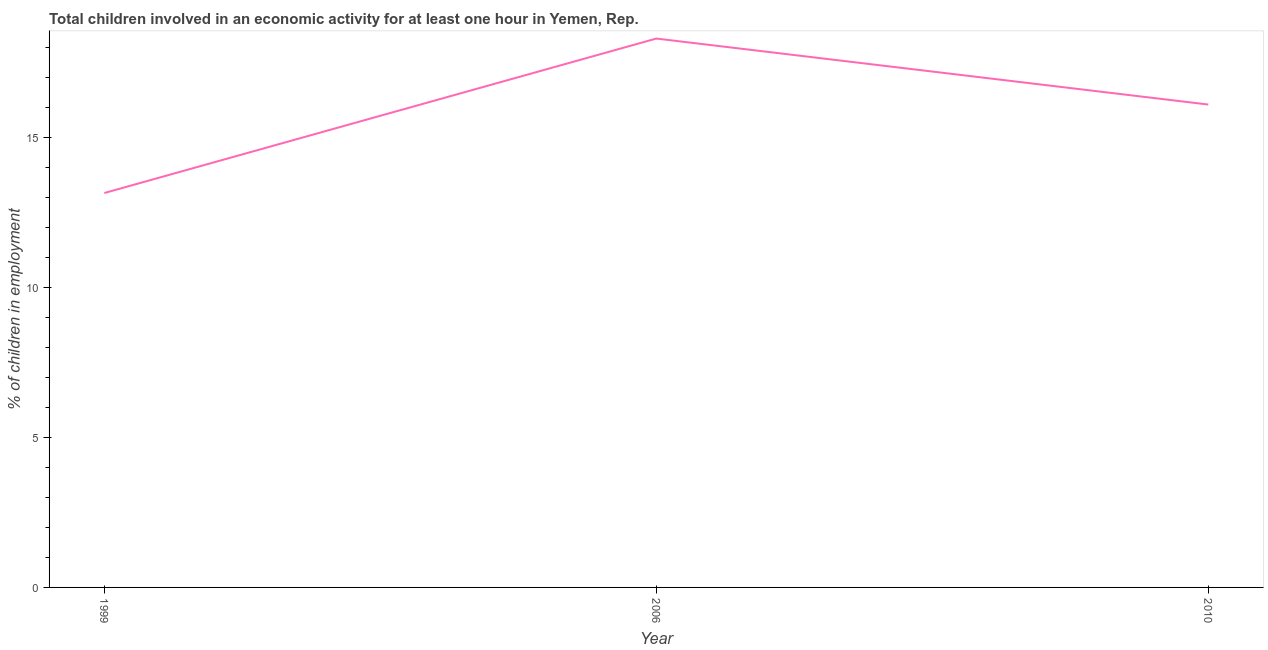What is the percentage of children in employment in 1999?
Provide a short and direct response. 13.15. Across all years, what is the maximum percentage of children in employment?
Keep it short and to the point. 18.3. Across all years, what is the minimum percentage of children in employment?
Your answer should be very brief. 13.15. What is the sum of the percentage of children in employment?
Offer a very short reply. 47.55. What is the difference between the percentage of children in employment in 1999 and 2010?
Your response must be concise. -2.95. What is the average percentage of children in employment per year?
Offer a terse response. 15.85. In how many years, is the percentage of children in employment greater than 4 %?
Provide a succinct answer. 3. Do a majority of the years between 2010 and 2006 (inclusive) have percentage of children in employment greater than 9 %?
Make the answer very short. No. What is the ratio of the percentage of children in employment in 2006 to that in 2010?
Make the answer very short. 1.14. Is the percentage of children in employment in 2006 less than that in 2010?
Your answer should be compact. No. What is the difference between the highest and the second highest percentage of children in employment?
Your response must be concise. 2.2. Is the sum of the percentage of children in employment in 1999 and 2010 greater than the maximum percentage of children in employment across all years?
Your answer should be very brief. Yes. What is the difference between the highest and the lowest percentage of children in employment?
Make the answer very short. 5.15. What is the difference between two consecutive major ticks on the Y-axis?
Ensure brevity in your answer.  5. Does the graph contain any zero values?
Your answer should be compact. No. Does the graph contain grids?
Make the answer very short. No. What is the title of the graph?
Keep it short and to the point. Total children involved in an economic activity for at least one hour in Yemen, Rep. What is the label or title of the Y-axis?
Your response must be concise. % of children in employment. What is the % of children in employment of 1999?
Offer a terse response. 13.15. What is the difference between the % of children in employment in 1999 and 2006?
Offer a terse response. -5.15. What is the difference between the % of children in employment in 1999 and 2010?
Give a very brief answer. -2.95. What is the difference between the % of children in employment in 2006 and 2010?
Provide a succinct answer. 2.2. What is the ratio of the % of children in employment in 1999 to that in 2006?
Your response must be concise. 0.72. What is the ratio of the % of children in employment in 1999 to that in 2010?
Ensure brevity in your answer.  0.82. What is the ratio of the % of children in employment in 2006 to that in 2010?
Give a very brief answer. 1.14. 